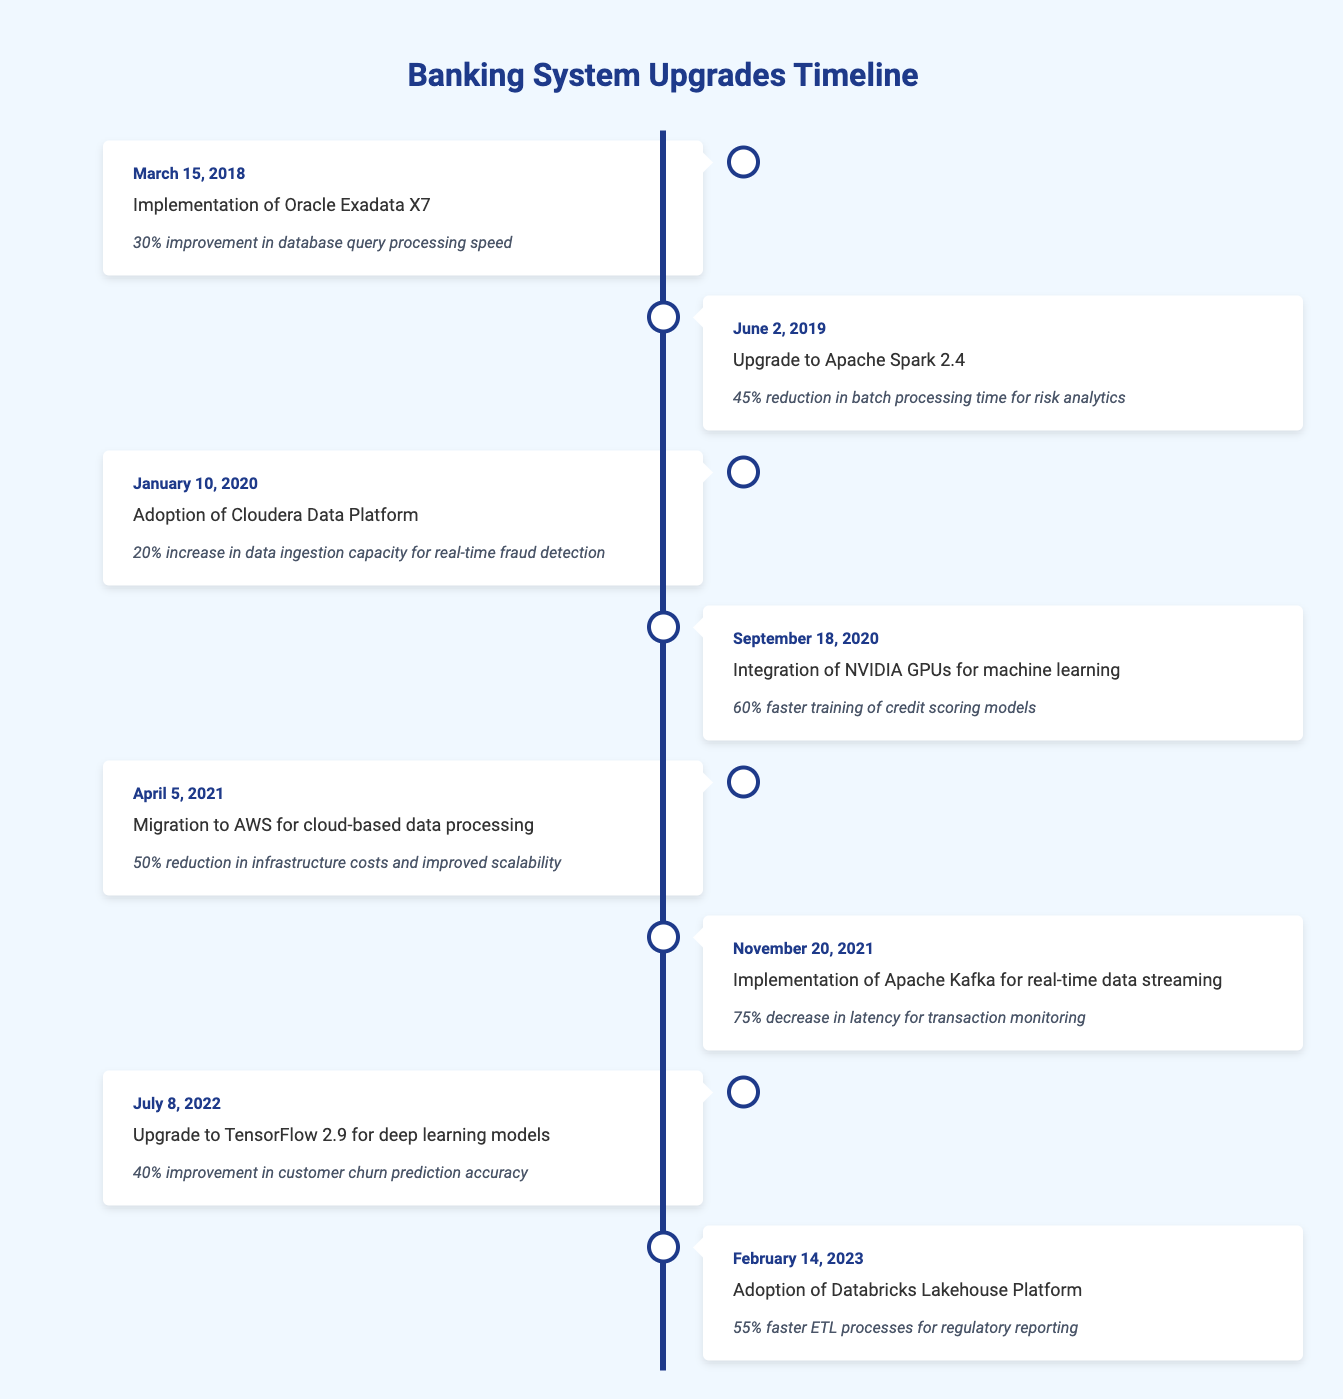What was the event that occurred on June 2, 2019? The event listed on June 2, 2019, is the "Upgrade to Apache Spark 2.4."
Answer: Upgrade to Apache Spark 2.4 What percentage improvement was achieved with the implementation of Oracle Exadata X7? The implementation of Oracle Exadata X7 resulted in a 30% improvement in database query processing speed.
Answer: 30% How many events resulted in a reduction in processing time? The events that resulted in a reduction in processing time are "Upgrade to Apache Spark 2.4" (45% reduction), "Integration of NVIDIA GPUs for machine learning" (60% faster training), and "Implementation of Apache Kafka for real-time data streaming" (75% decrease in latency). Thus, there are three events.
Answer: 3 What is the average percentage improvement among the upgrades that mention increased efficiency? The improvements are 30%, 45%, 20%, 60%, 50%, 75%, 40%, and 55%. Adding them gives 30 + 45 + 20 + 60 + 50 + 75 + 40 + 55 = 375. There are 8 improvements, so the average is 375 / 8 = 46.875%.
Answer: 46.88% Was there a system upgrade in 2021 that focused on cloud-based processing? Yes, the event "Migration to AWS for cloud-based data processing" took place on April 5, 2021.
Answer: Yes Which upgrade had the highest reported efficiency improvement? The upgrade with the highest reported efficiency improvement is the "Implementation of Apache Kafka for real-time data streaming," which had a 75% decrease in latency.
Answer: 75% How did the integration of NVIDIA GPUs impact credit scoring models? The integration of NVIDIA GPUs resulted in a 60% faster training time for credit scoring models.
Answer: 60% Which two upgrades focused specifically on improving data processing speed? The two upgrades focusing on improving data processing speed are "Implementation of Oracle Exadata X7" (30% improvement) and "Implementation of Apache Kafka for real-time data streaming" (75% decrease in latency).
Answer: Oracle Exadata X7 and Apache Kafka 